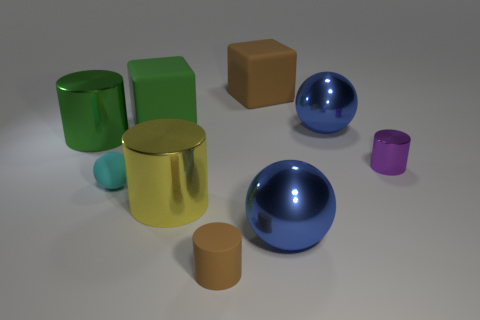How many spheres are in front of the large brown matte thing right of the green metallic thing?
Your response must be concise. 3. Does the large thing behind the green rubber object have the same color as the tiny matte object to the right of the green rubber thing?
Your answer should be very brief. Yes. What material is the brown cylinder that is the same size as the cyan rubber object?
Ensure brevity in your answer.  Rubber. There is a brown matte object that is in front of the tiny shiny cylinder that is right of the cylinder that is behind the tiny purple metal object; what is its shape?
Offer a very short reply. Cylinder. The green matte thing that is the same size as the green shiny thing is what shape?
Provide a succinct answer. Cube. What number of green rubber things are behind the big brown matte block behind the big blue shiny thing that is in front of the large yellow shiny thing?
Provide a short and direct response. 0. Is the number of green matte objects that are behind the large yellow object greater than the number of cyan matte spheres that are behind the green metal thing?
Offer a terse response. Yes. What number of large green rubber objects are the same shape as the cyan matte thing?
Ensure brevity in your answer.  0. How many things are large metal cylinders behind the small cyan ball or big rubber blocks on the left side of the yellow shiny thing?
Your response must be concise. 2. There is a thing to the right of the blue object behind the large blue shiny sphere in front of the yellow object; what is it made of?
Ensure brevity in your answer.  Metal. 